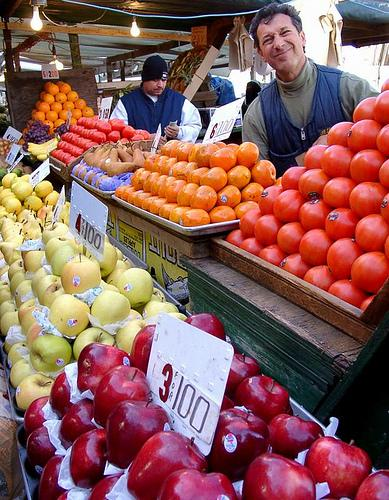What is the name of the red apples?

Choices:
A) ladybug
B) red delicious
C) dark red
D) savory red delicious 